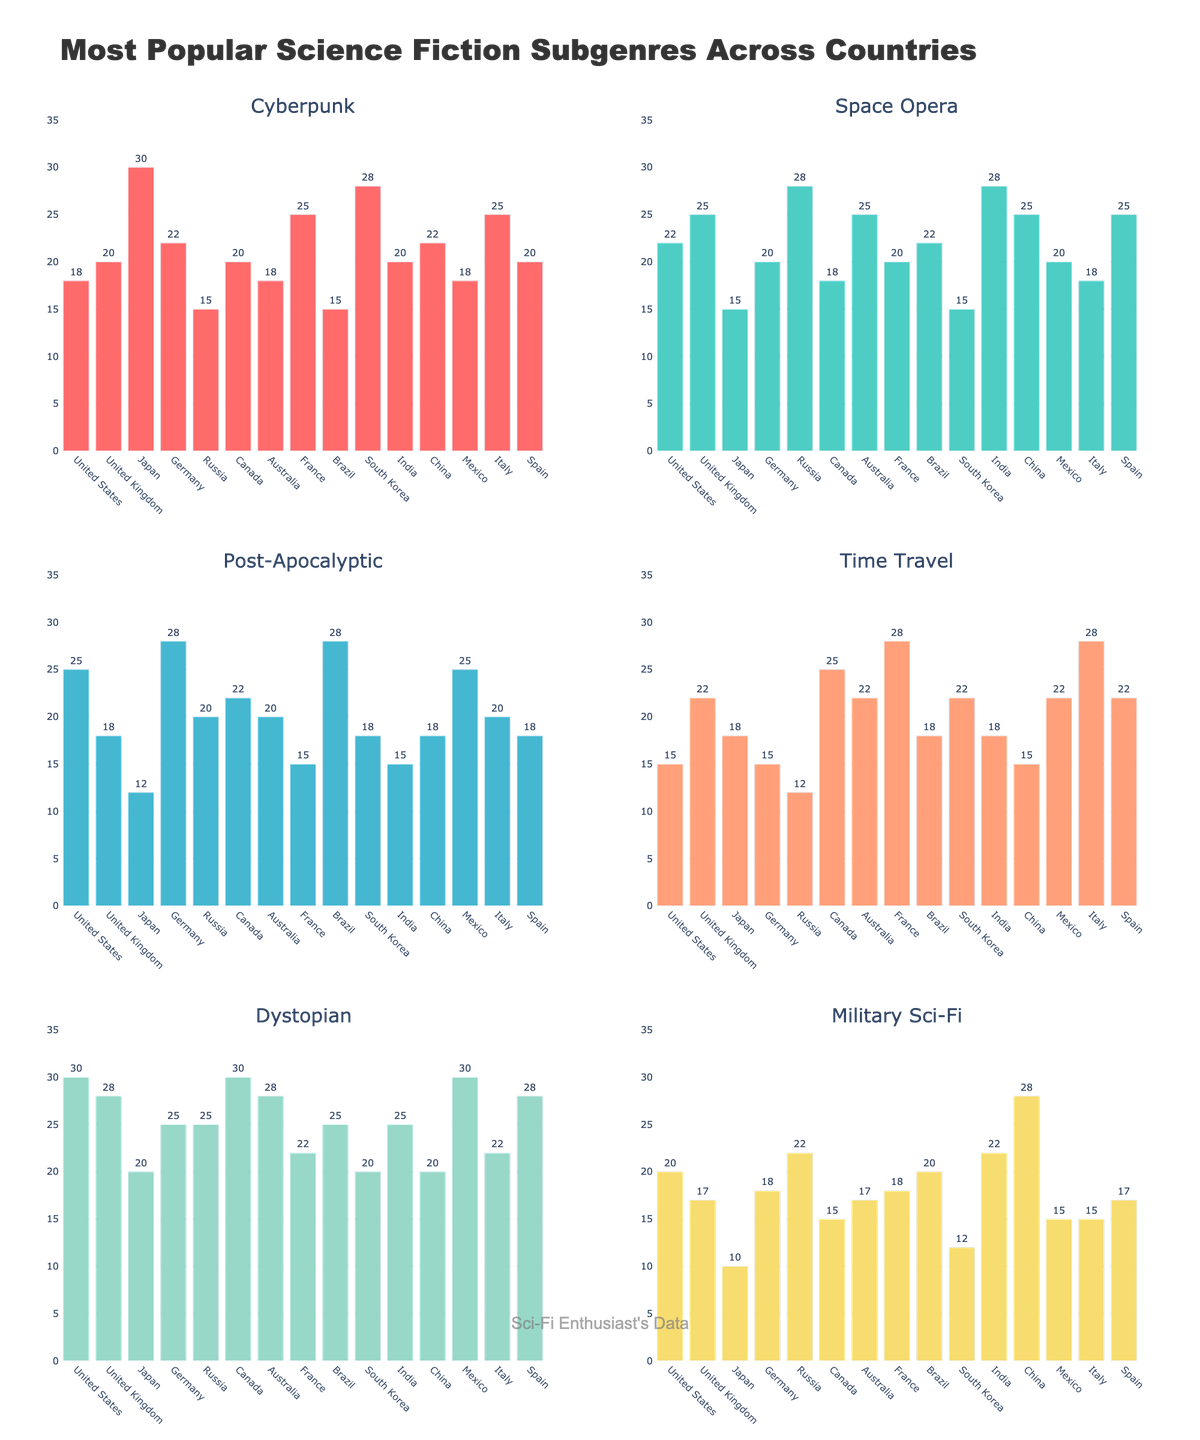Which country has the highest popularity for Cyberpunk? The bar for Cyberpunk is tallest for Japan, indicating that Cyberpunk is most popular there.
Answer: Japan Which subgenre is the most popular in the United States? By looking at the heights of the bars for each subgenre in the United States, the Dystopian subgenre has the tallest bar.
Answer: Dystopian Is Military Sci-Fi more popular in China or Russia? The bar for Military Sci-Fi is taller for China compared to Russia.
Answer: China What is the average popularity of Time Travel in the United Kingdom and Canada? Sum the values for Time Travel in the United Kingdom (22) and Canada (25), then divide by 2 to find the average: (22 + 25) / 2 = 23.5
Answer: 23.5 Which country has the least popularity for Space Opera? The bar for Space Opera is shortest for Japan.
Answer: Japan In which subgenre does Brazil have highest popularity? For Brazil, the highest bar is for Post-Apocalyptic.
Answer: Post-Apocalyptic Which subgenre has the most even popularity across all countries? Looking across all the subplots, Cyberpunk has more similarly sized bars across countries compared to other subgenres.
Answer: Cyberpunk How does France's preference for Time Travel compare to Germany's? The bar for Time Travel is taller for France (28) than for Germany (15).
Answer: France What is the total popularity of Dystopian in the United States, United Kingdom, and Australia? Sum the values for Dystopian in these countries: United States (30) + United Kingdom (28) + Australia (28) = 86
Answer: 86 Which subgenre is least popular in South Korea? By comparing all the bars for South Korea, Military Sci-Fi has the shortest bar.
Answer: Military Sci-Fi 